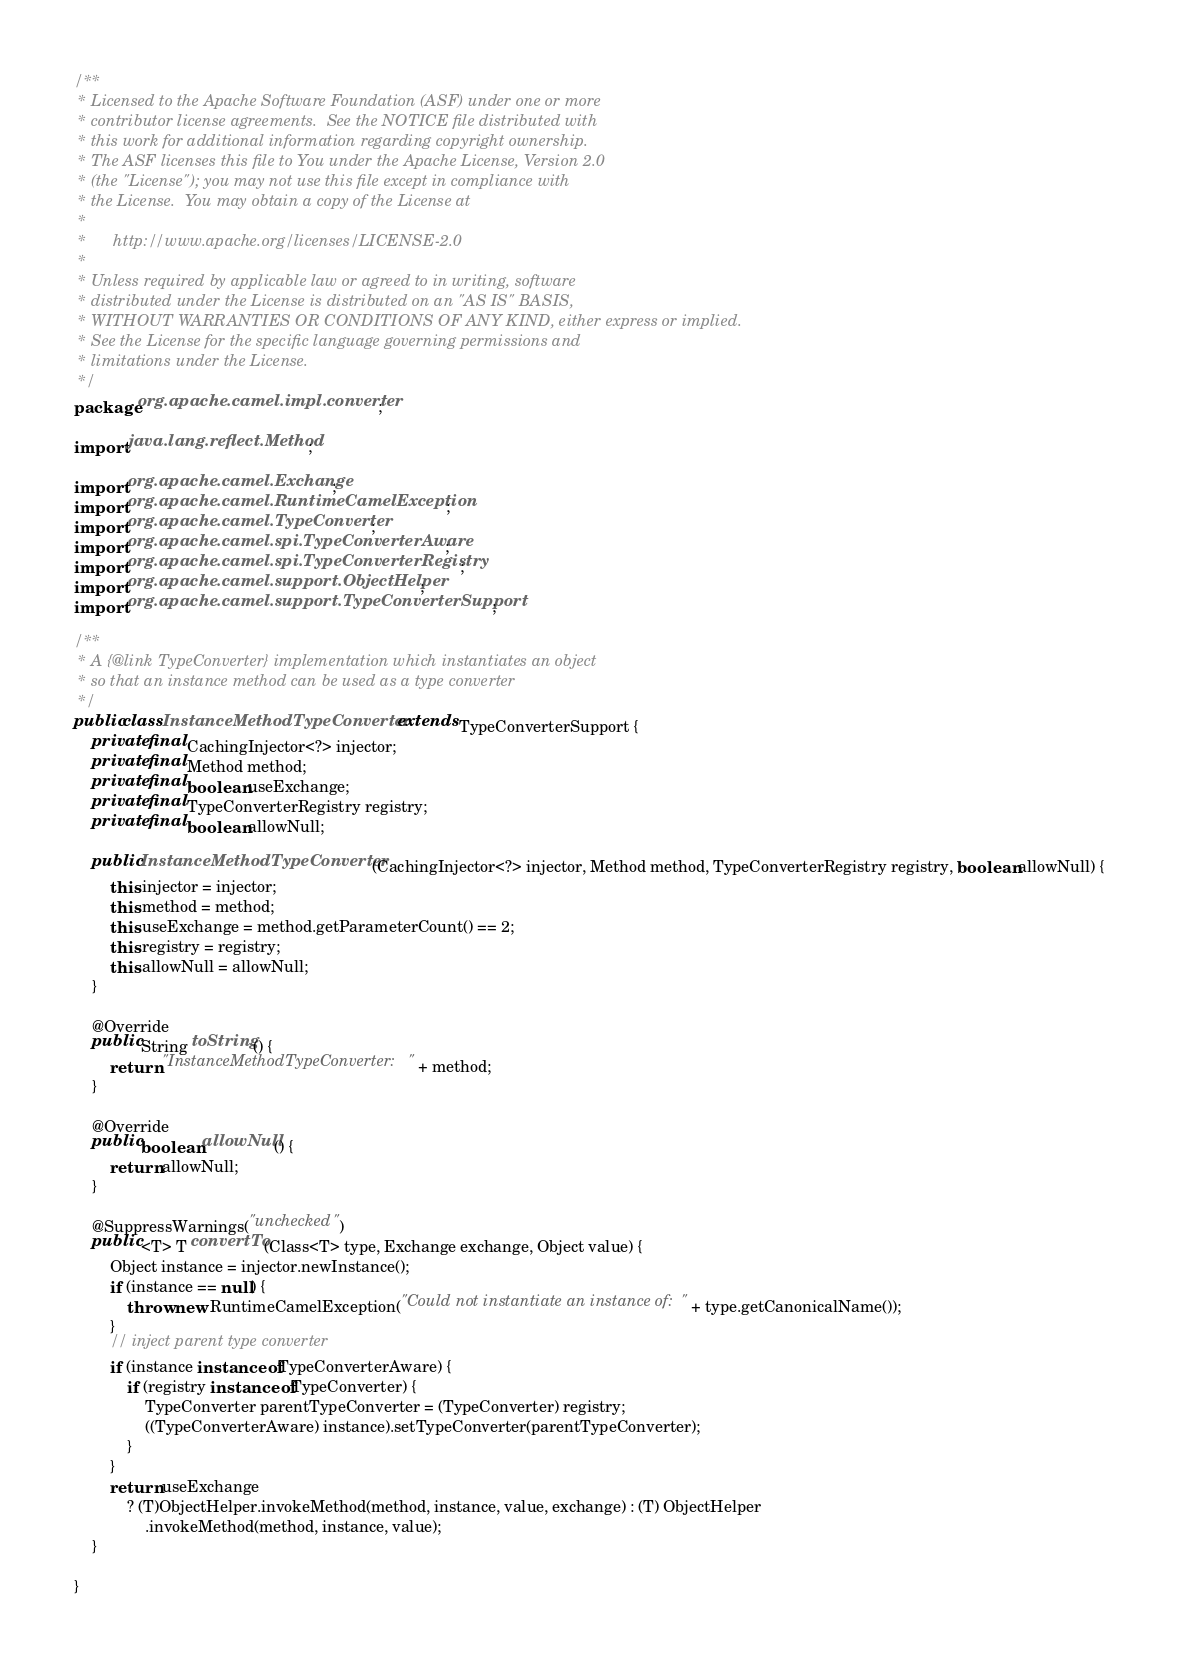<code> <loc_0><loc_0><loc_500><loc_500><_Java_>/**
 * Licensed to the Apache Software Foundation (ASF) under one or more
 * contributor license agreements.  See the NOTICE file distributed with
 * this work for additional information regarding copyright ownership.
 * The ASF licenses this file to You under the Apache License, Version 2.0
 * (the "License"); you may not use this file except in compliance with
 * the License.  You may obtain a copy of the License at
 *
 *      http://www.apache.org/licenses/LICENSE-2.0
 *
 * Unless required by applicable law or agreed to in writing, software
 * distributed under the License is distributed on an "AS IS" BASIS,
 * WITHOUT WARRANTIES OR CONDITIONS OF ANY KIND, either express or implied.
 * See the License for the specific language governing permissions and
 * limitations under the License.
 */
package org.apache.camel.impl.converter;

import java.lang.reflect.Method;

import org.apache.camel.Exchange;
import org.apache.camel.RuntimeCamelException;
import org.apache.camel.TypeConverter;
import org.apache.camel.spi.TypeConverterAware;
import org.apache.camel.spi.TypeConverterRegistry;
import org.apache.camel.support.ObjectHelper;
import org.apache.camel.support.TypeConverterSupport;

/**
 * A {@link TypeConverter} implementation which instantiates an object
 * so that an instance method can be used as a type converter
 */
public class InstanceMethodTypeConverter extends TypeConverterSupport {
    private final CachingInjector<?> injector;
    private final Method method;
    private final boolean useExchange;
    private final TypeConverterRegistry registry;
    private final boolean allowNull;

    public InstanceMethodTypeConverter(CachingInjector<?> injector, Method method, TypeConverterRegistry registry, boolean allowNull) {
        this.injector = injector;
        this.method = method;
        this.useExchange = method.getParameterCount() == 2;
        this.registry = registry;
        this.allowNull = allowNull;
    }

    @Override
    public String toString() {
        return "InstanceMethodTypeConverter: " + method;
    }

    @Override
    public boolean allowNull() {
        return allowNull;
    }

    @SuppressWarnings("unchecked")
    public <T> T convertTo(Class<T> type, Exchange exchange, Object value) {
        Object instance = injector.newInstance();
        if (instance == null) {
            throw new RuntimeCamelException("Could not instantiate an instance of: " + type.getCanonicalName());
        }
        // inject parent type converter
        if (instance instanceof TypeConverterAware) {
            if (registry instanceof TypeConverter) {
                TypeConverter parentTypeConverter = (TypeConverter) registry;
                ((TypeConverterAware) instance).setTypeConverter(parentTypeConverter);
            }
        }
        return useExchange
            ? (T)ObjectHelper.invokeMethod(method, instance, value, exchange) : (T) ObjectHelper
                .invokeMethod(method, instance, value);
    }

}
</code> 